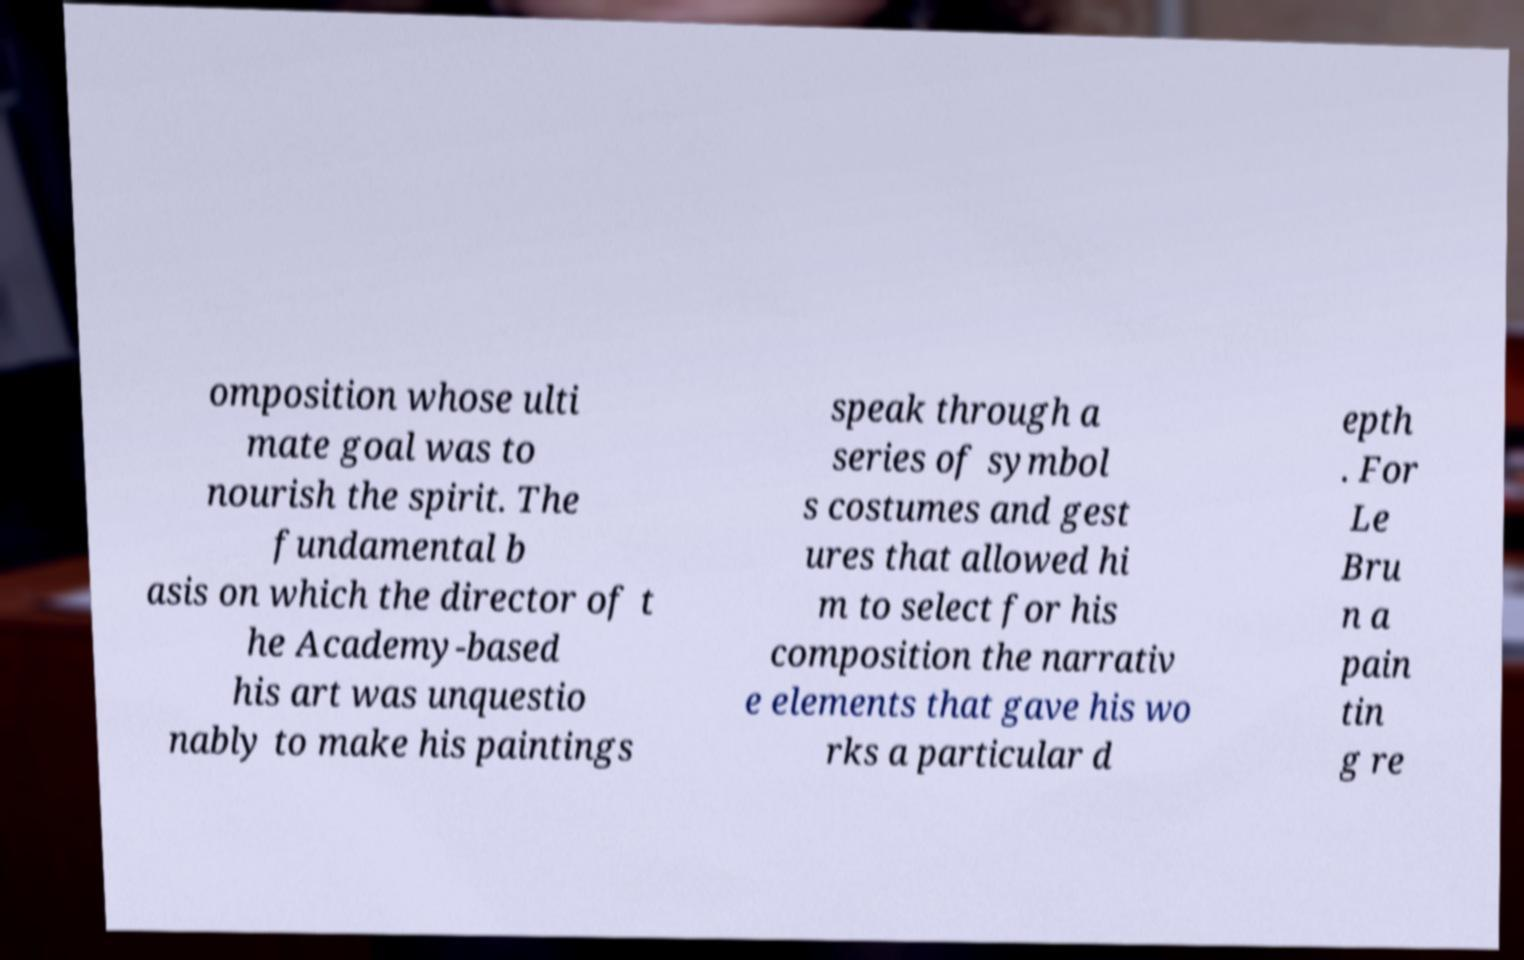Can you read and provide the text displayed in the image?This photo seems to have some interesting text. Can you extract and type it out for me? omposition whose ulti mate goal was to nourish the spirit. The fundamental b asis on which the director of t he Academy-based his art was unquestio nably to make his paintings speak through a series of symbol s costumes and gest ures that allowed hi m to select for his composition the narrativ e elements that gave his wo rks a particular d epth . For Le Bru n a pain tin g re 